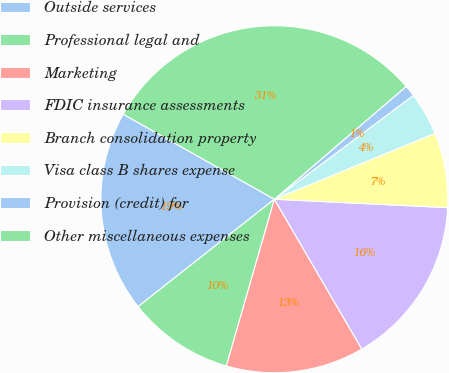<chart> <loc_0><loc_0><loc_500><loc_500><pie_chart><fcel>Outside services<fcel>Professional legal and<fcel>Marketing<fcel>FDIC insurance assessments<fcel>Branch consolidation property<fcel>Visa class B shares expense<fcel>Provision (credit) for<fcel>Other miscellaneous expenses<nl><fcel>18.77%<fcel>9.92%<fcel>12.87%<fcel>15.82%<fcel>6.97%<fcel>4.01%<fcel>1.06%<fcel>30.58%<nl></chart> 